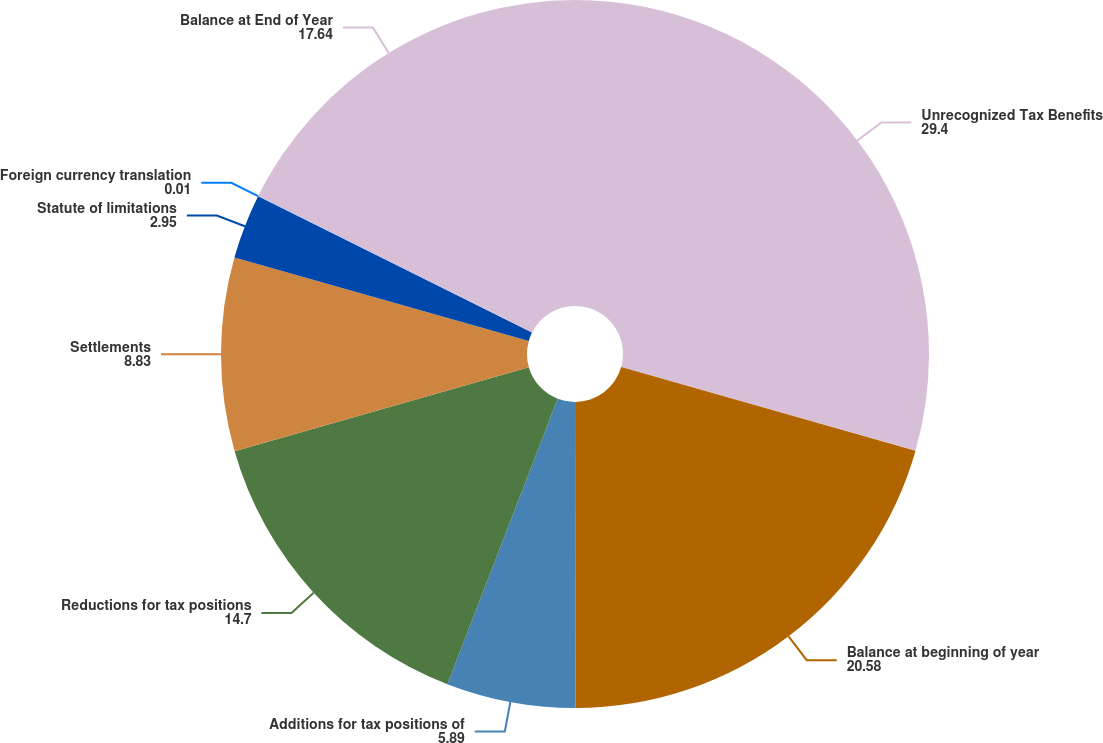Convert chart to OTSL. <chart><loc_0><loc_0><loc_500><loc_500><pie_chart><fcel>Unrecognized Tax Benefits<fcel>Balance at beginning of year<fcel>Additions for tax positions of<fcel>Reductions for tax positions<fcel>Settlements<fcel>Statute of limitations<fcel>Foreign currency translation<fcel>Balance at End of Year<nl><fcel>29.4%<fcel>20.58%<fcel>5.89%<fcel>14.7%<fcel>8.83%<fcel>2.95%<fcel>0.01%<fcel>17.64%<nl></chart> 